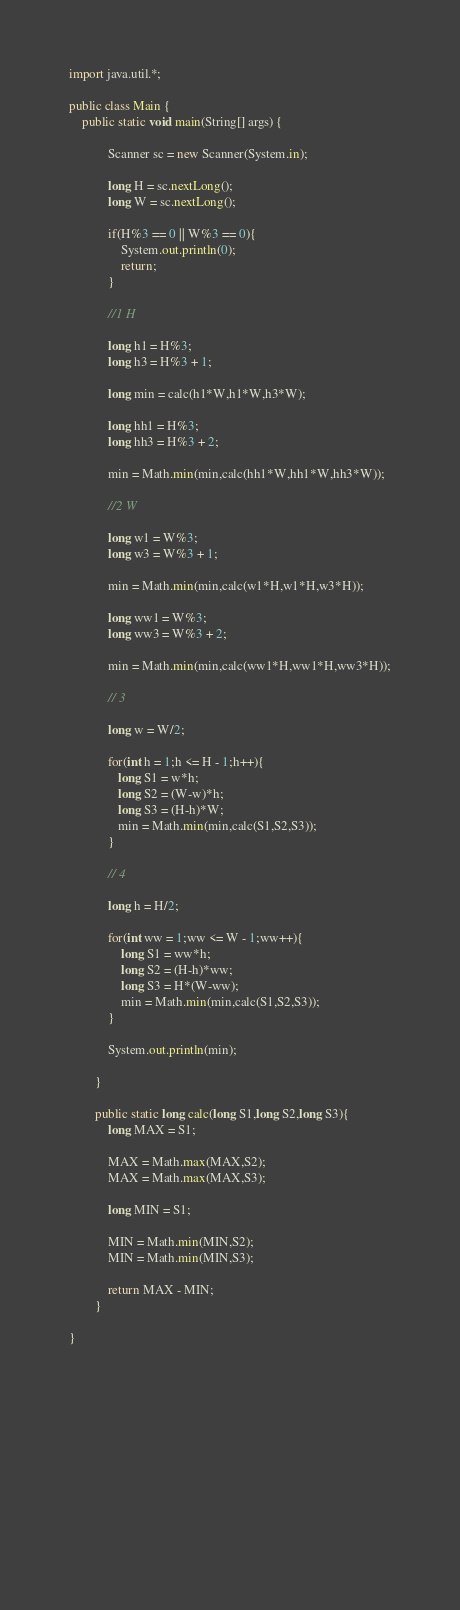<code> <loc_0><loc_0><loc_500><loc_500><_Java_>import java.util.*;

public class Main {
	public static void main(String[] args) {
		 
            Scanner sc = new Scanner(System.in);
            
            long H = sc.nextLong();
            long W = sc.nextLong();         
            
            if(H%3 == 0 || W%3 == 0){
                System.out.println(0);
                return;
            }
            
            //1 H 
                        
            long h1 = H%3;
            long h3 = H%3 + 1;
            
            long min = calc(h1*W,h1*W,h3*W);
            
            long hh1 = H%3;
            long hh3 = H%3 + 2;
                        
            min = Math.min(min,calc(hh1*W,hh1*W,hh3*W));
            
            //2 W
            
            long w1 = W%3;
            long w3 = W%3 + 1;
            
            min = Math.min(min,calc(w1*H,w1*H,w3*H));
            
            long ww1 = W%3;
            long ww3 = W%3 + 2;
            
            min = Math.min(min,calc(ww1*H,ww1*H,ww3*H));
                                    
            // 3
                        
            long w = W/2;
            
            for(int h = 1;h <= H - 1;h++){
               long S1 = w*h;
               long S2 = (W-w)*h;
               long S3 = (H-h)*W;
               min = Math.min(min,calc(S1,S2,S3));
            }                
            
            // 4            
                  
            long h = H/2;
            
            for(int ww = 1;ww <= W - 1;ww++){
                long S1 = ww*h;
                long S2 = (H-h)*ww;
                long S3 = H*(W-ww);
                min = Math.min(min,calc(S1,S2,S3));
            }                            
            
            System.out.println(min);
            
        }
        
        public static long calc(long S1,long S2,long S3){
            long MAX = S1;                        
            
            MAX = Math.max(MAX,S2);            
            MAX = Math.max(MAX,S3);
            
            long MIN = S1;
            
            MIN = Math.min(MIN,S2);
            MIN = Math.min(MIN,S3);
           
            return MAX - MIN;            
        }
        
}

        
        
        
        
        
        
        
        
        
        
        </code> 